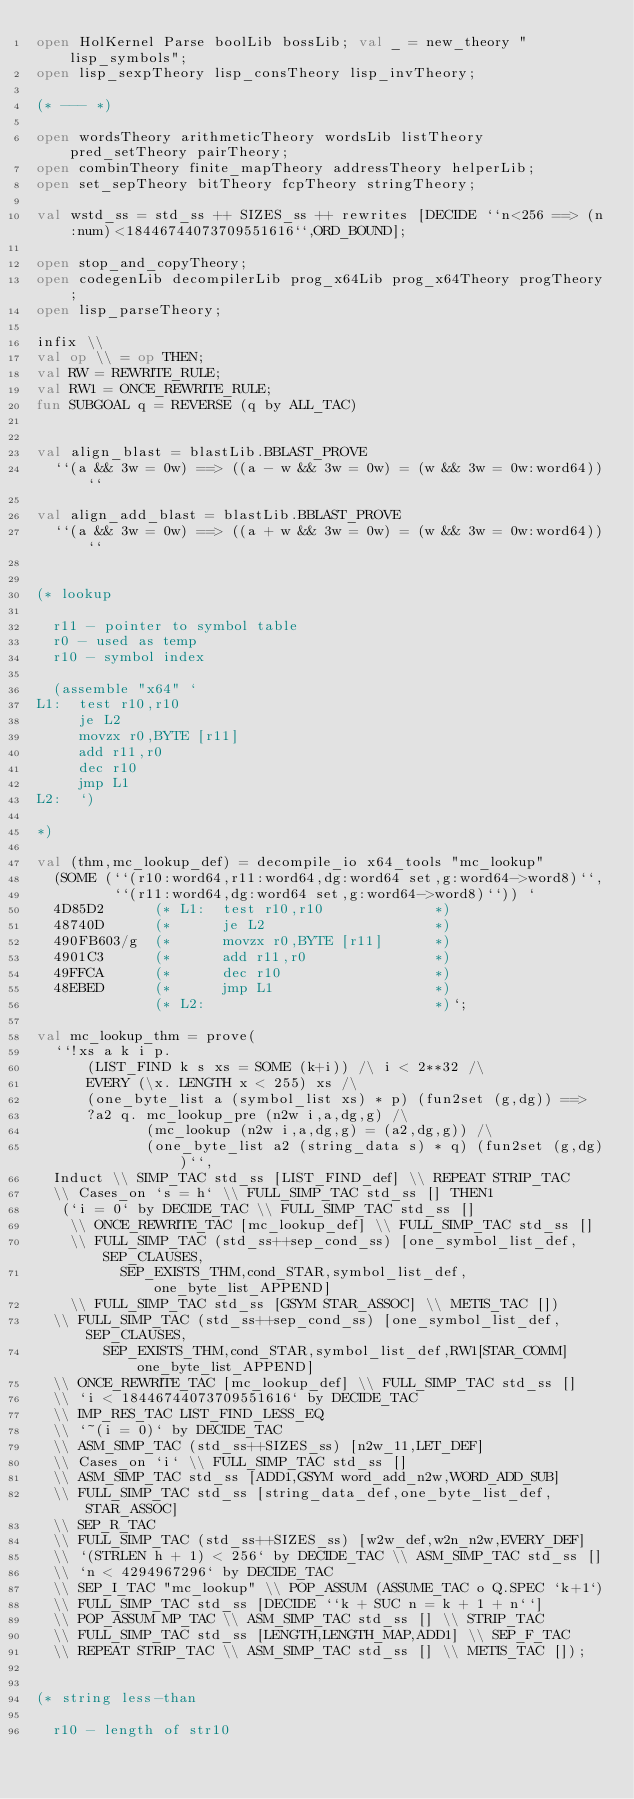Convert code to text. <code><loc_0><loc_0><loc_500><loc_500><_SML_>open HolKernel Parse boolLib bossLib; val _ = new_theory "lisp_symbols";
open lisp_sexpTheory lisp_consTheory lisp_invTheory;

(* --- *)

open wordsTheory arithmeticTheory wordsLib listTheory pred_setTheory pairTheory;
open combinTheory finite_mapTheory addressTheory helperLib;
open set_sepTheory bitTheory fcpTheory stringTheory;

val wstd_ss = std_ss ++ SIZES_ss ++ rewrites [DECIDE ``n<256 ==> (n:num)<18446744073709551616``,ORD_BOUND];

open stop_and_copyTheory;
open codegenLib decompilerLib prog_x64Lib prog_x64Theory progTheory;
open lisp_parseTheory;

infix \\
val op \\ = op THEN;
val RW = REWRITE_RULE;
val RW1 = ONCE_REWRITE_RULE;
fun SUBGOAL q = REVERSE (q by ALL_TAC)


val align_blast = blastLib.BBLAST_PROVE
  ``(a && 3w = 0w) ==> ((a - w && 3w = 0w) = (w && 3w = 0w:word64))``

val align_add_blast = blastLib.BBLAST_PROVE
  ``(a && 3w = 0w) ==> ((a + w && 3w = 0w) = (w && 3w = 0w:word64))``


(* lookup

  r11 - pointer to symbol table
  r0 - used as temp
  r10 - symbol index

  (assemble "x64" `
L1:  test r10,r10
     je L2
     movzx r0,BYTE [r11]
     add r11,r0
     dec r10
     jmp L1
L2:  `)

*)

val (thm,mc_lookup_def) = decompile_io x64_tools "mc_lookup"
  (SOME (``(r10:word64,r11:word64,dg:word64 set,g:word64->word8)``,
         ``(r11:word64,dg:word64 set,g:word64->word8)``)) `
  4D85D2      (* L1:  test r10,r10             *)
  48740D      (*      je L2                    *)
  490FB603/g  (*      movzx r0,BYTE [r11]      *)
  4901C3      (*      add r11,r0               *)
  49FFCA      (*      dec r10                  *)
  48EBED      (*      jmp L1                   *)
              (* L2:                           *)`;

val mc_lookup_thm = prove(
  ``!xs a k i p.
      (LIST_FIND k s xs = SOME (k+i)) /\ i < 2**32 /\
      EVERY (\x. LENGTH x < 255) xs /\
      (one_byte_list a (symbol_list xs) * p) (fun2set (g,dg)) ==>
      ?a2 q. mc_lookup_pre (n2w i,a,dg,g) /\
             (mc_lookup (n2w i,a,dg,g) = (a2,dg,g)) /\
             (one_byte_list a2 (string_data s) * q) (fun2set (g,dg))``,
  Induct \\ SIMP_TAC std_ss [LIST_FIND_def] \\ REPEAT STRIP_TAC
  \\ Cases_on `s = h` \\ FULL_SIMP_TAC std_ss [] THEN1
   (`i = 0` by DECIDE_TAC \\ FULL_SIMP_TAC std_ss []
    \\ ONCE_REWRITE_TAC [mc_lookup_def] \\ FULL_SIMP_TAC std_ss []
    \\ FULL_SIMP_TAC (std_ss++sep_cond_ss) [one_symbol_list_def,SEP_CLAUSES,
          SEP_EXISTS_THM,cond_STAR,symbol_list_def,one_byte_list_APPEND]
    \\ FULL_SIMP_TAC std_ss [GSYM STAR_ASSOC] \\ METIS_TAC [])
  \\ FULL_SIMP_TAC (std_ss++sep_cond_ss) [one_symbol_list_def,SEP_CLAUSES,
        SEP_EXISTS_THM,cond_STAR,symbol_list_def,RW1[STAR_COMM]one_byte_list_APPEND]
  \\ ONCE_REWRITE_TAC [mc_lookup_def] \\ FULL_SIMP_TAC std_ss []
  \\ `i < 18446744073709551616` by DECIDE_TAC
  \\ IMP_RES_TAC LIST_FIND_LESS_EQ
  \\ `~(i = 0)` by DECIDE_TAC
  \\ ASM_SIMP_TAC (std_ss++SIZES_ss) [n2w_11,LET_DEF]
  \\ Cases_on `i` \\ FULL_SIMP_TAC std_ss []
  \\ ASM_SIMP_TAC std_ss [ADD1,GSYM word_add_n2w,WORD_ADD_SUB]
  \\ FULL_SIMP_TAC std_ss [string_data_def,one_byte_list_def,STAR_ASSOC]
  \\ SEP_R_TAC
  \\ FULL_SIMP_TAC (std_ss++SIZES_ss) [w2w_def,w2n_n2w,EVERY_DEF]
  \\ `(STRLEN h + 1) < 256` by DECIDE_TAC \\ ASM_SIMP_TAC std_ss []
  \\ `n < 4294967296` by DECIDE_TAC
  \\ SEP_I_TAC "mc_lookup" \\ POP_ASSUM (ASSUME_TAC o Q.SPEC `k+1`)
  \\ FULL_SIMP_TAC std_ss [DECIDE ``k + SUC n = k + 1 + n``]
  \\ POP_ASSUM MP_TAC \\ ASM_SIMP_TAC std_ss [] \\ STRIP_TAC
  \\ FULL_SIMP_TAC std_ss [LENGTH,LENGTH_MAP,ADD1] \\ SEP_F_TAC
  \\ REPEAT STRIP_TAC \\ ASM_SIMP_TAC std_ss [] \\ METIS_TAC []);


(* string less-than

  r10 - length of str10</code> 